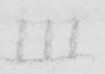What does this handwritten line say? III 